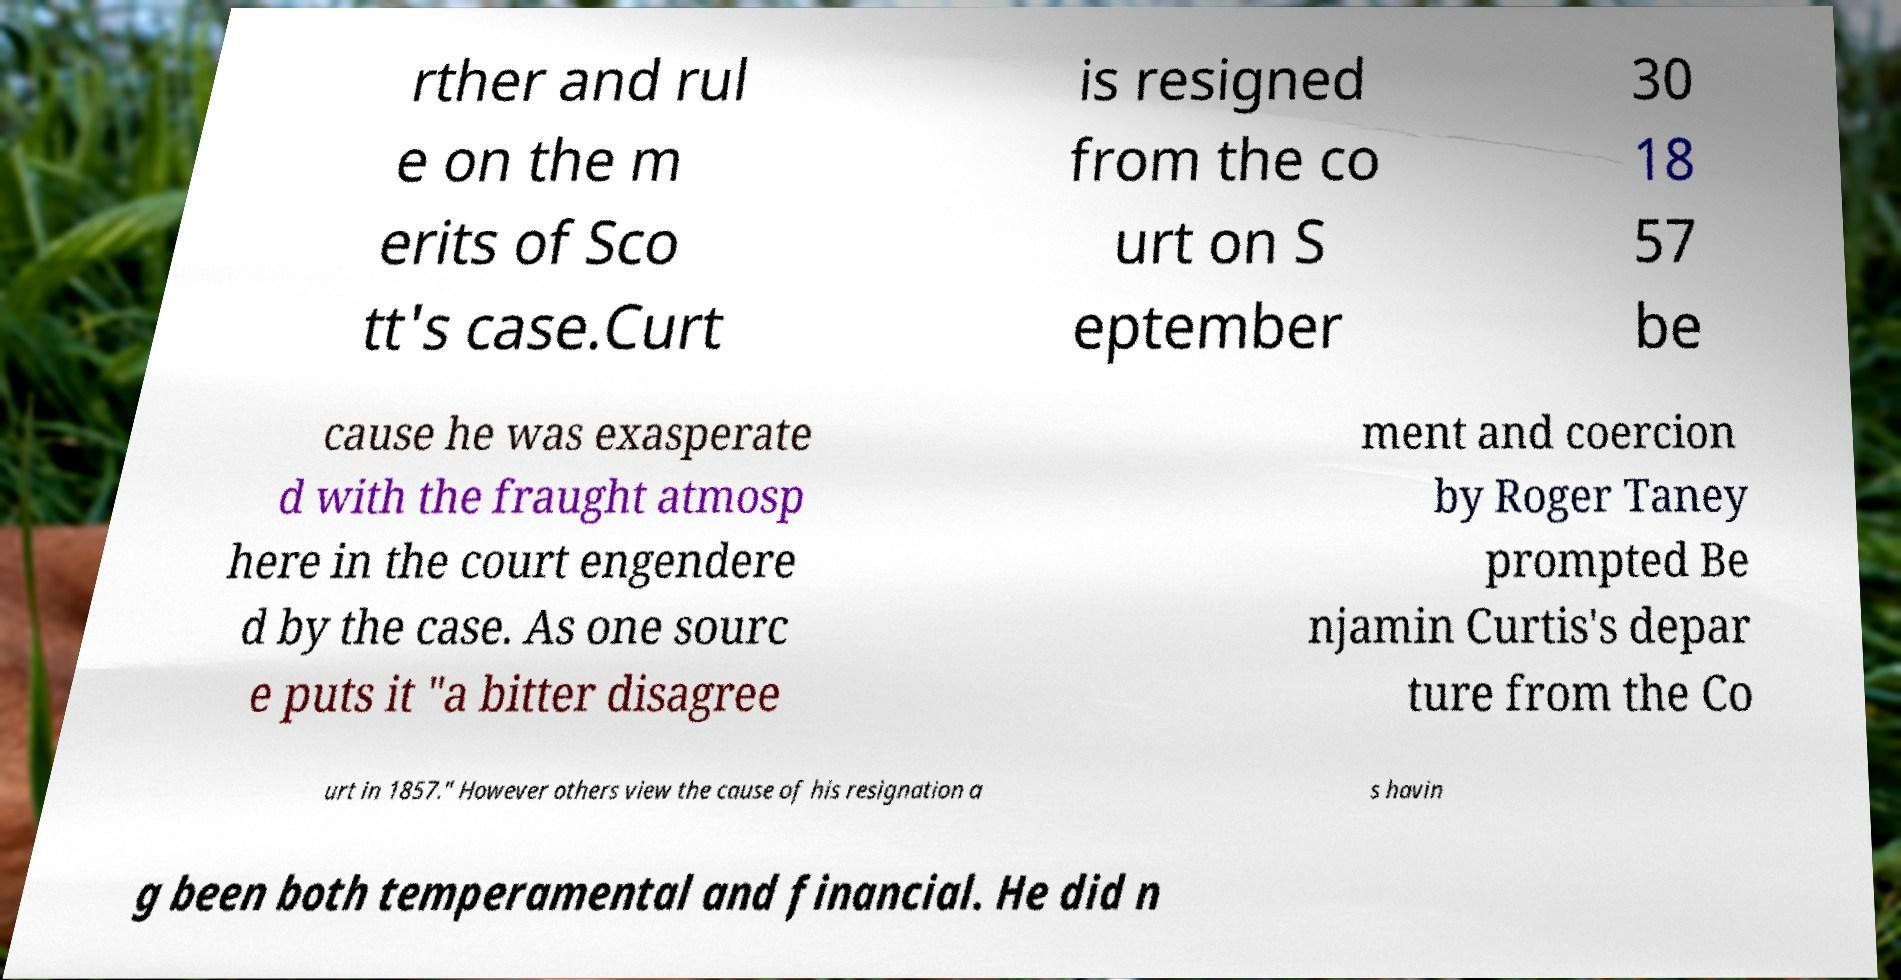Can you accurately transcribe the text from the provided image for me? rther and rul e on the m erits of Sco tt's case.Curt is resigned from the co urt on S eptember 30 18 57 be cause he was exasperate d with the fraught atmosp here in the court engendere d by the case. As one sourc e puts it "a bitter disagree ment and coercion by Roger Taney prompted Be njamin Curtis's depar ture from the Co urt in 1857." However others view the cause of his resignation a s havin g been both temperamental and financial. He did n 